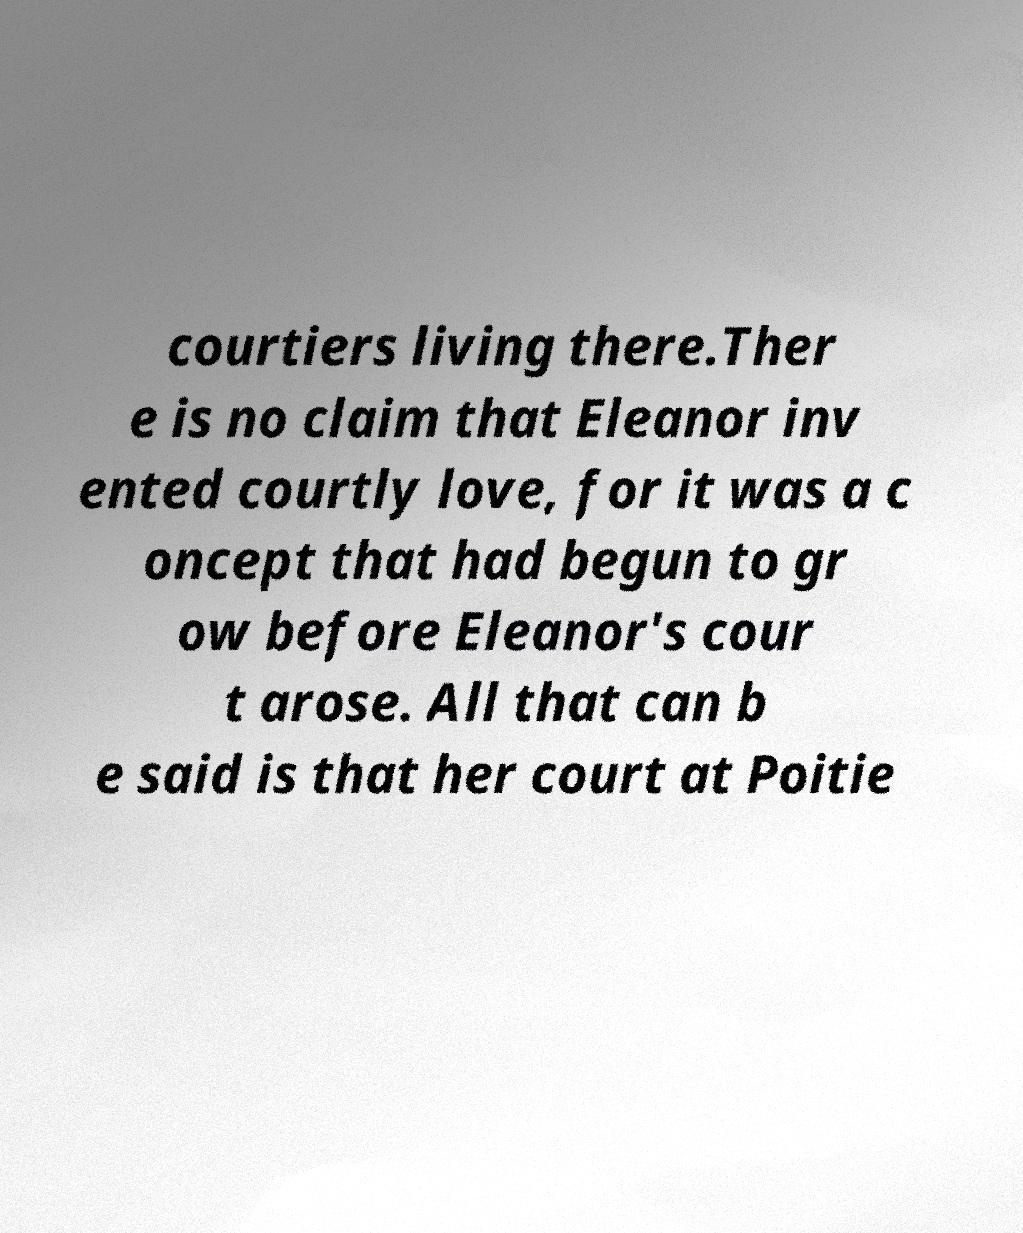Please identify and transcribe the text found in this image. courtiers living there.Ther e is no claim that Eleanor inv ented courtly love, for it was a c oncept that had begun to gr ow before Eleanor's cour t arose. All that can b e said is that her court at Poitie 